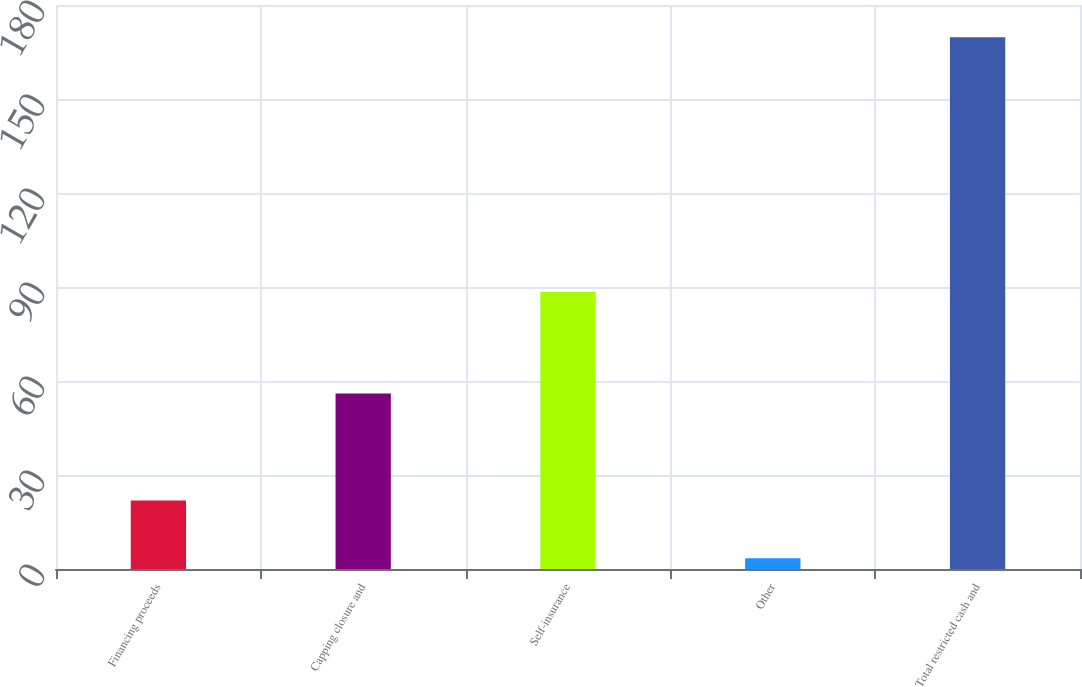Convert chart to OTSL. <chart><loc_0><loc_0><loc_500><loc_500><bar_chart><fcel>Financing proceeds<fcel>Capping closure and<fcel>Self-insurance<fcel>Other<fcel>Total restricted cash and<nl><fcel>21.9<fcel>56<fcel>88.4<fcel>3.4<fcel>169.7<nl></chart> 